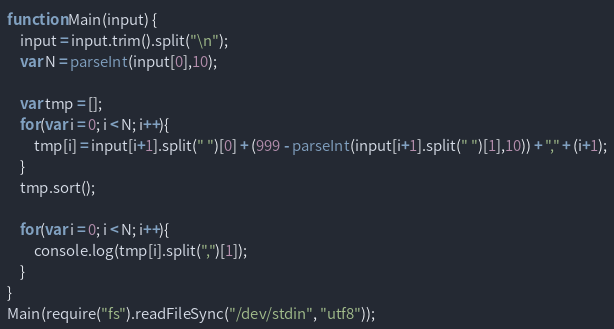<code> <loc_0><loc_0><loc_500><loc_500><_JavaScript_>function Main(input) {
    input = input.trim().split("\n");
    var N = parseInt(input[0],10);

    var tmp = [];
    for(var i = 0; i < N; i++){
        tmp[i] = input[i+1].split(" ")[0] + (999 - parseInt(input[i+1].split(" ")[1],10)) + "," + (i+1);
    }
    tmp.sort();

    for(var i = 0; i < N; i++){
        console.log(tmp[i].split(",")[1]);
    }
}
Main(require("fs").readFileSync("/dev/stdin", "utf8"));</code> 